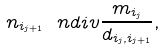<formula> <loc_0><loc_0><loc_500><loc_500>n _ { i _ { j + 1 } } \ n d i v \frac { m _ { i _ { j } } } { d _ { i _ { j } , i _ { j + 1 } } } ,</formula> 